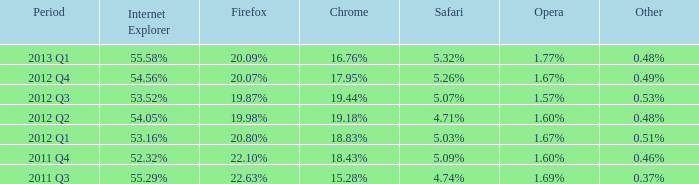What internet explorer has 1.67% as the opera, with 2012 q1 as the period? 53.16%. 